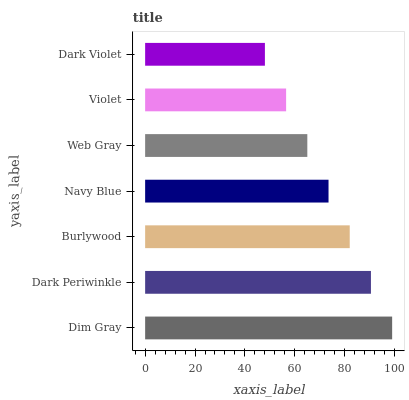Is Dark Violet the minimum?
Answer yes or no. Yes. Is Dim Gray the maximum?
Answer yes or no. Yes. Is Dark Periwinkle the minimum?
Answer yes or no. No. Is Dark Periwinkle the maximum?
Answer yes or no. No. Is Dim Gray greater than Dark Periwinkle?
Answer yes or no. Yes. Is Dark Periwinkle less than Dim Gray?
Answer yes or no. Yes. Is Dark Periwinkle greater than Dim Gray?
Answer yes or no. No. Is Dim Gray less than Dark Periwinkle?
Answer yes or no. No. Is Navy Blue the high median?
Answer yes or no. Yes. Is Navy Blue the low median?
Answer yes or no. Yes. Is Dark Violet the high median?
Answer yes or no. No. Is Web Gray the low median?
Answer yes or no. No. 